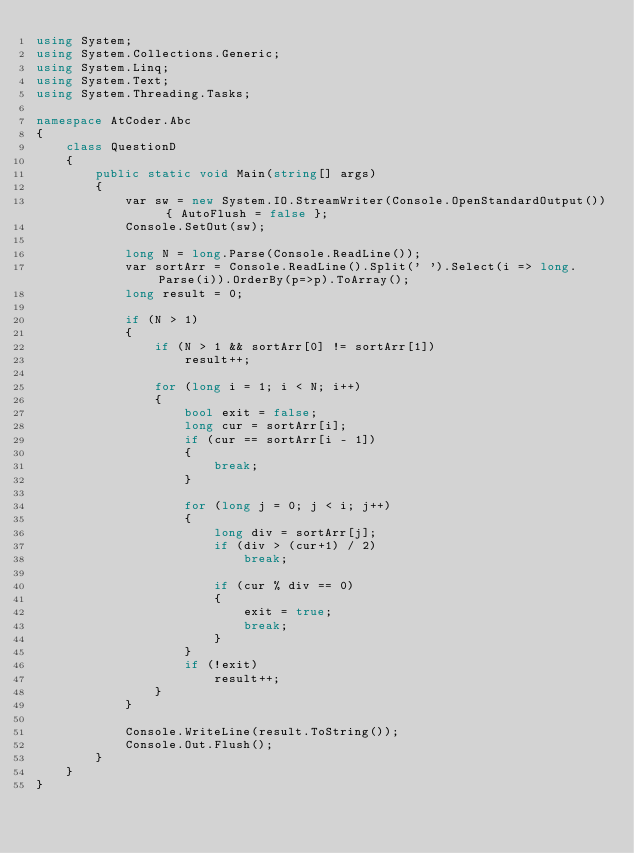Convert code to text. <code><loc_0><loc_0><loc_500><loc_500><_C#_>using System;
using System.Collections.Generic;
using System.Linq;
using System.Text;
using System.Threading.Tasks;

namespace AtCoder.Abc
{
    class QuestionD
    {
        public static void Main(string[] args)
        {
            var sw = new System.IO.StreamWriter(Console.OpenStandardOutput()) { AutoFlush = false };
            Console.SetOut(sw);

            long N = long.Parse(Console.ReadLine());
            var sortArr = Console.ReadLine().Split(' ').Select(i => long.Parse(i)).OrderBy(p=>p).ToArray();
            long result = 0;

            if (N > 1)
            {
                if (N > 1 && sortArr[0] != sortArr[1])
                    result++;

                for (long i = 1; i < N; i++)
                {
                    bool exit = false;
                    long cur = sortArr[i];
                    if (cur == sortArr[i - 1])
                    {
                        break;
                    }

                    for (long j = 0; j < i; j++)
                    {
                        long div = sortArr[j];
                        if (div > (cur+1) / 2)
                            break;

                        if (cur % div == 0)
                        {
                            exit = true;
                            break;
                        }
                    }
                    if (!exit)
                        result++;
                }
            }

            Console.WriteLine(result.ToString());
            Console.Out.Flush();
        }
    }
}
</code> 